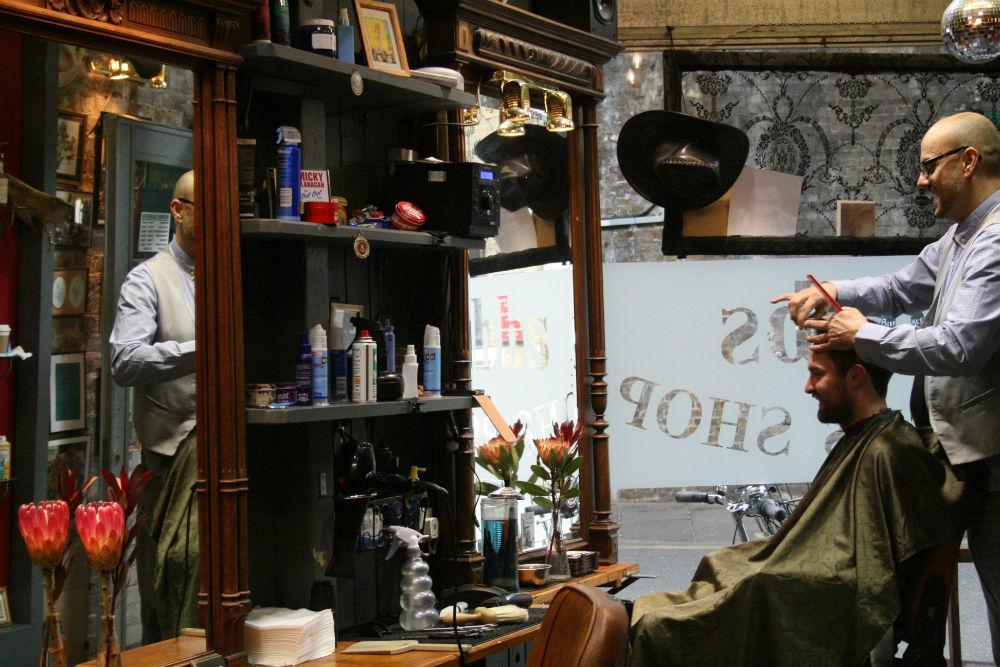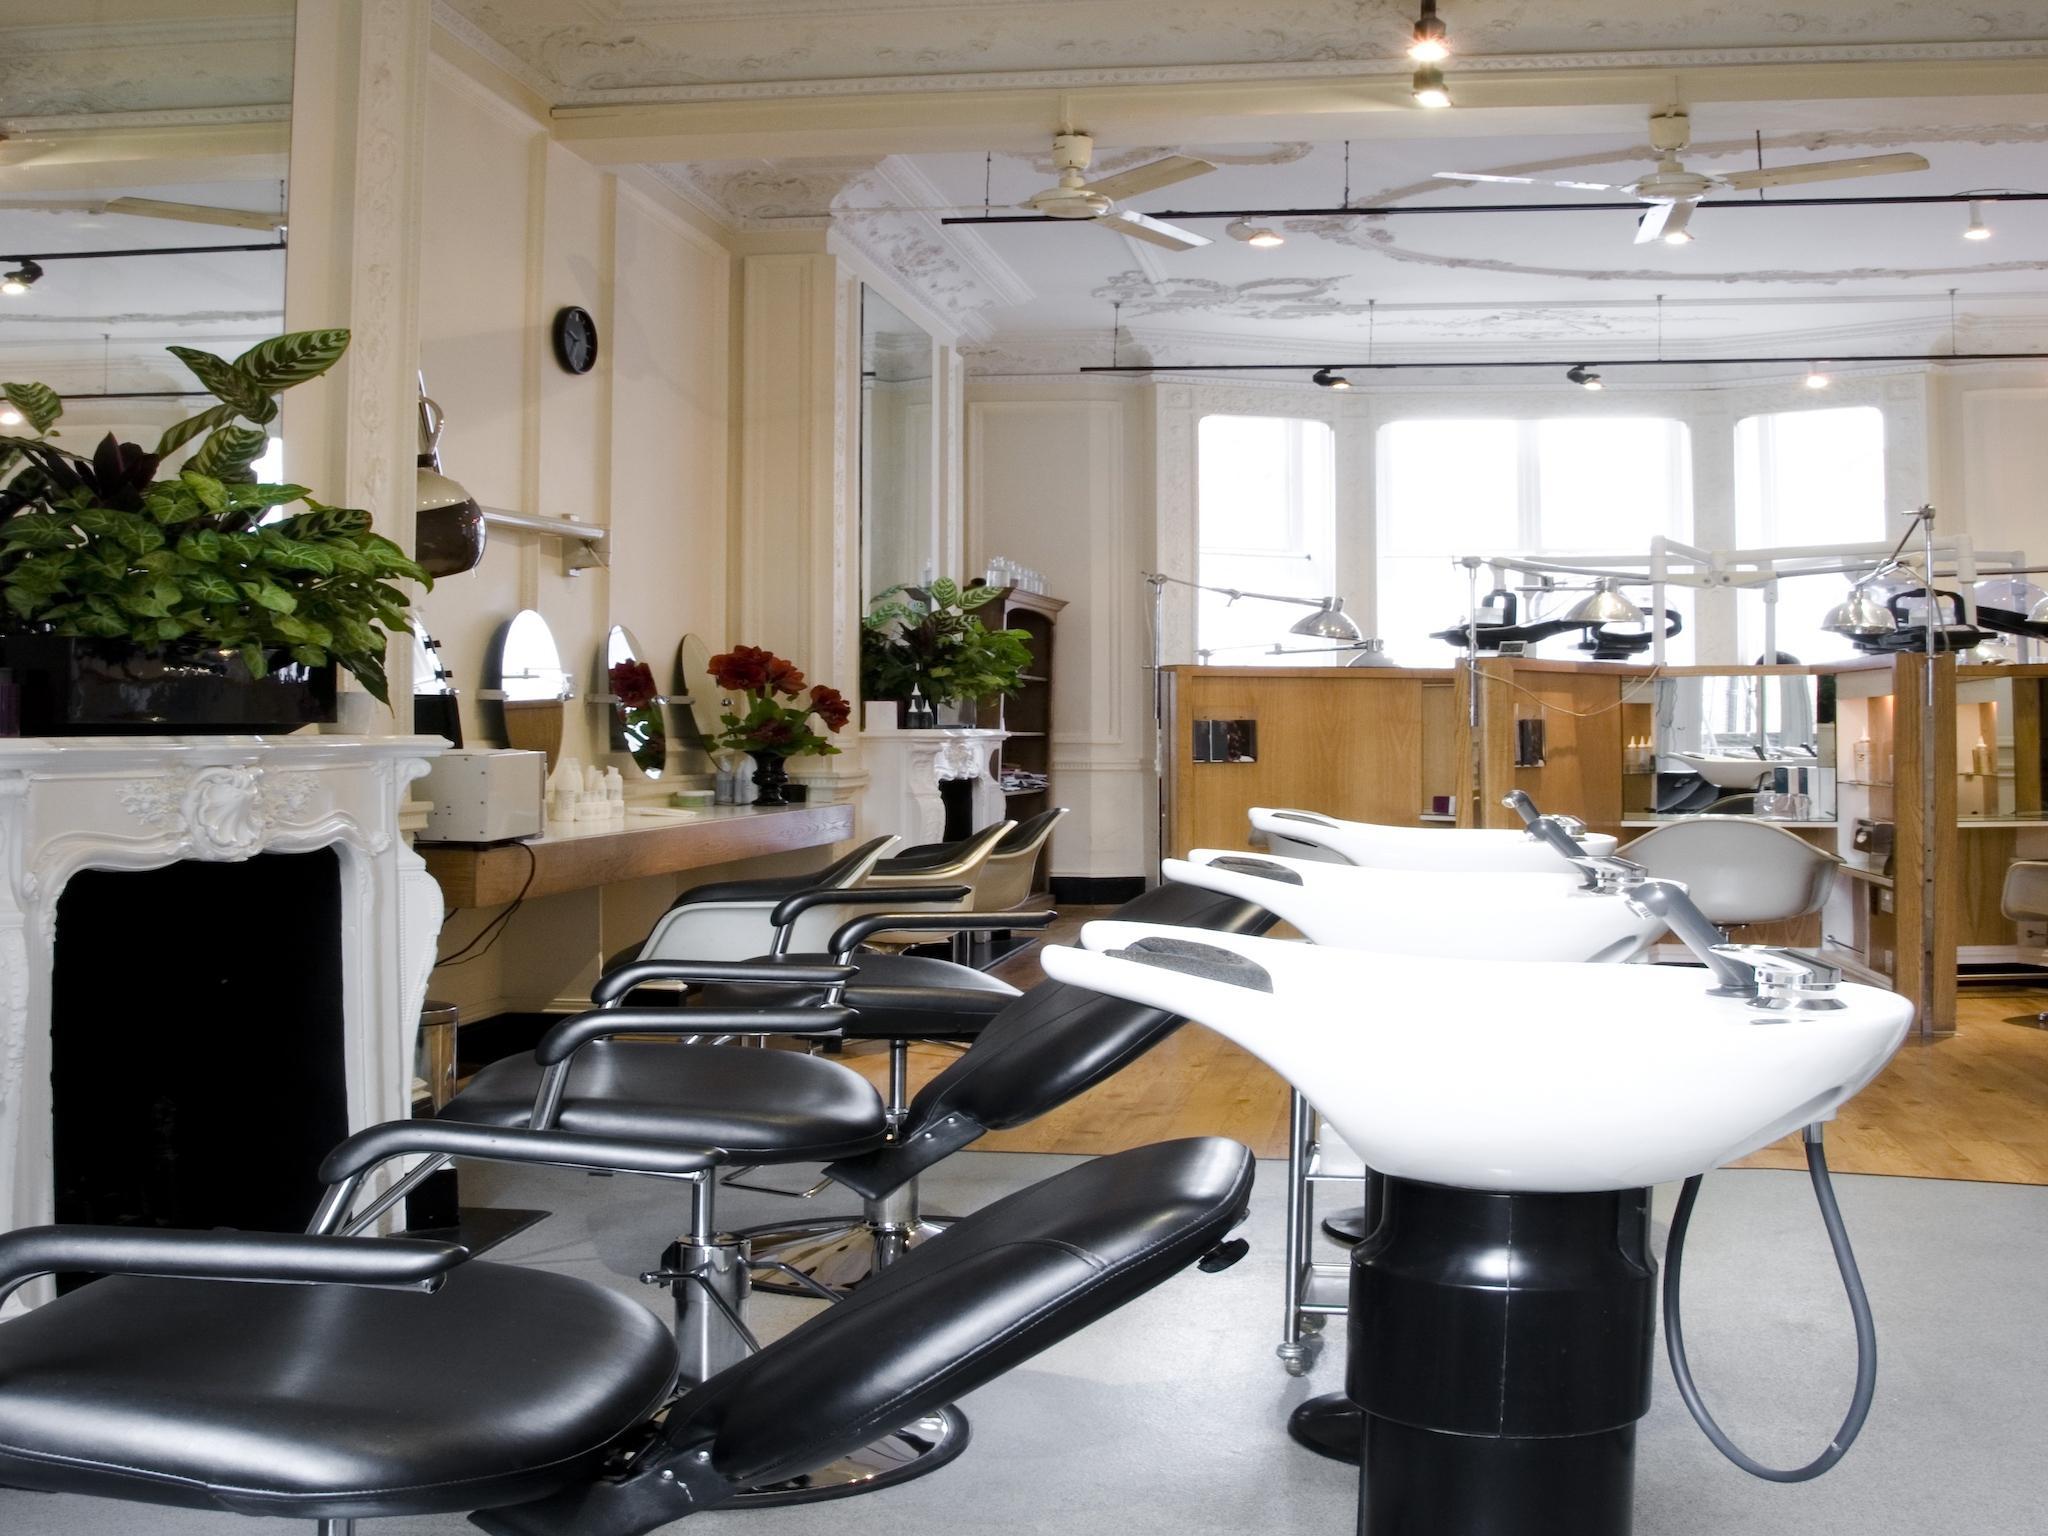The first image is the image on the left, the second image is the image on the right. Considering the images on both sides, is "There are exactly two people in the left image." valid? Answer yes or no. Yes. The first image is the image on the left, the second image is the image on the right. Analyze the images presented: Is the assertion "In at least one image there are two visible faces in the barbershop." valid? Answer yes or no. Yes. 